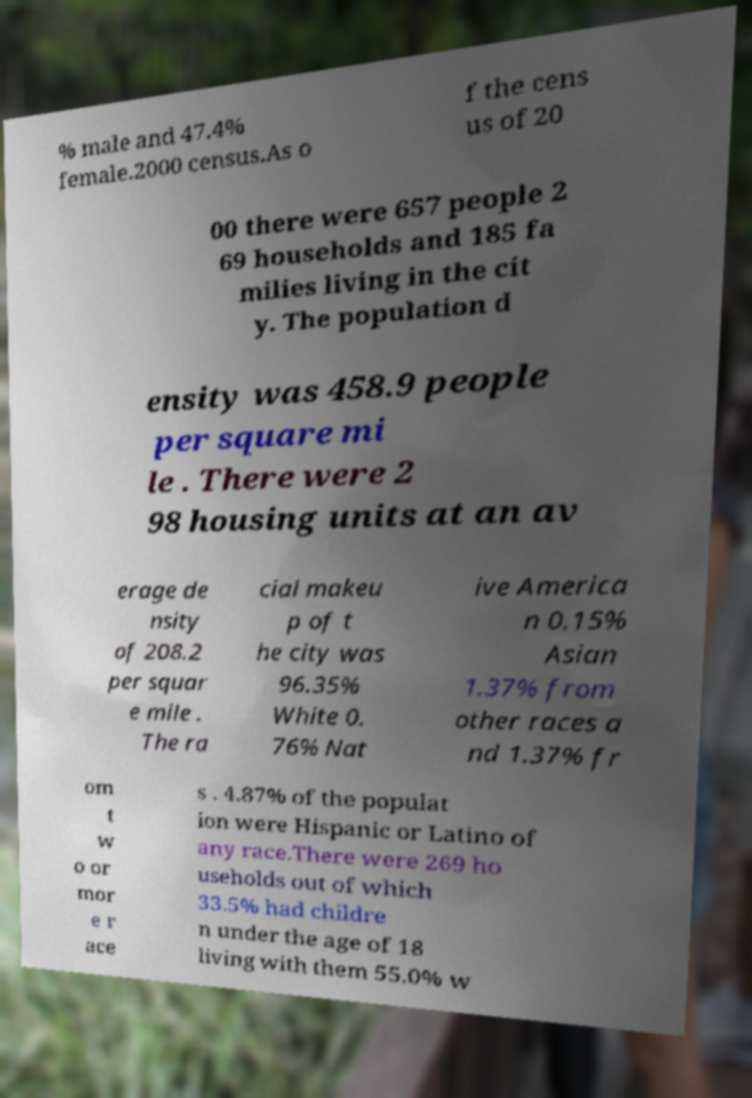I need the written content from this picture converted into text. Can you do that? % male and 47.4% female.2000 census.As o f the cens us of 20 00 there were 657 people 2 69 households and 185 fa milies living in the cit y. The population d ensity was 458.9 people per square mi le . There were 2 98 housing units at an av erage de nsity of 208.2 per squar e mile . The ra cial makeu p of t he city was 96.35% White 0. 76% Nat ive America n 0.15% Asian 1.37% from other races a nd 1.37% fr om t w o or mor e r ace s . 4.87% of the populat ion were Hispanic or Latino of any race.There were 269 ho useholds out of which 33.5% had childre n under the age of 18 living with them 55.0% w 